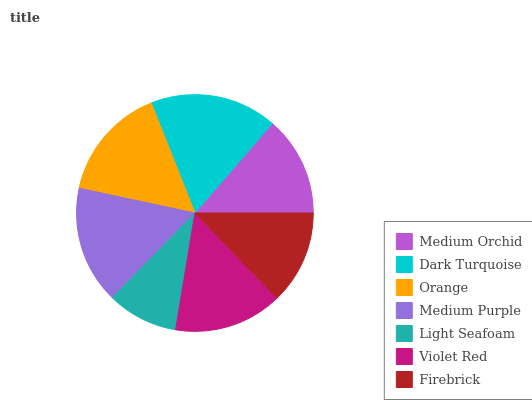Is Light Seafoam the minimum?
Answer yes or no. Yes. Is Dark Turquoise the maximum?
Answer yes or no. Yes. Is Orange the minimum?
Answer yes or no. No. Is Orange the maximum?
Answer yes or no. No. Is Dark Turquoise greater than Orange?
Answer yes or no. Yes. Is Orange less than Dark Turquoise?
Answer yes or no. Yes. Is Orange greater than Dark Turquoise?
Answer yes or no. No. Is Dark Turquoise less than Orange?
Answer yes or no. No. Is Violet Red the high median?
Answer yes or no. Yes. Is Violet Red the low median?
Answer yes or no. Yes. Is Light Seafoam the high median?
Answer yes or no. No. Is Medium Purple the low median?
Answer yes or no. No. 